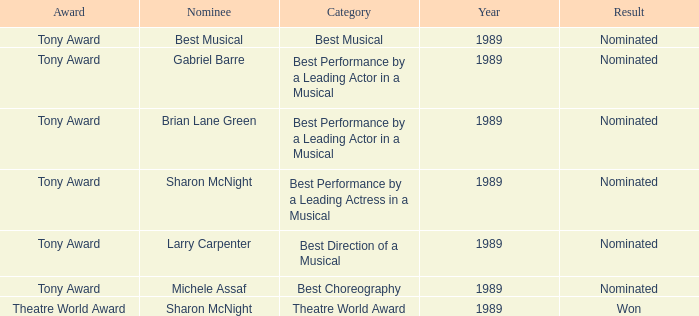What year was michele assaf nominated 1989.0. 